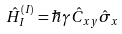<formula> <loc_0><loc_0><loc_500><loc_500>\hat { H } ^ { ( I ) } _ { I } = \hbar { \gamma } \hat { C } _ { x y } \hat { \sigma } _ { x }</formula> 